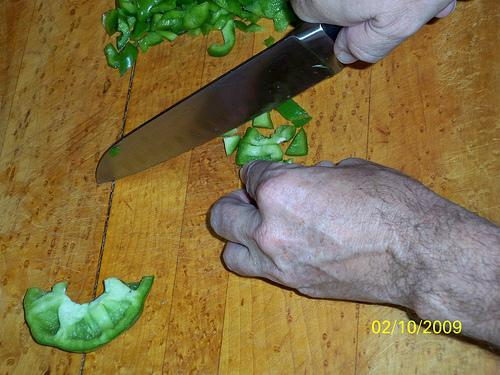Question: why does the person have knife?
Choices:
A. For cutting.
B. For slicing.
C. For dicing.
D. For chopping.
Answer with the letter. Answer: D Question: what does the food being chopped appear to be?
Choices:
A. Onion.
B. Garlic.
C. Bell pepper.
D. Carrot.
Answer with the letter. Answer: C Question: who took this photo?
Choices:
A. Camera man.
B. Video Grapher.
C. Photographer.
D. Painter.
Answer with the letter. Answer: C Question: what could chopping style being performed be called?
Choices:
A. Dicing.
B. Slicing.
C. Cutting.
D. Mincing.
Answer with the letter. Answer: A 